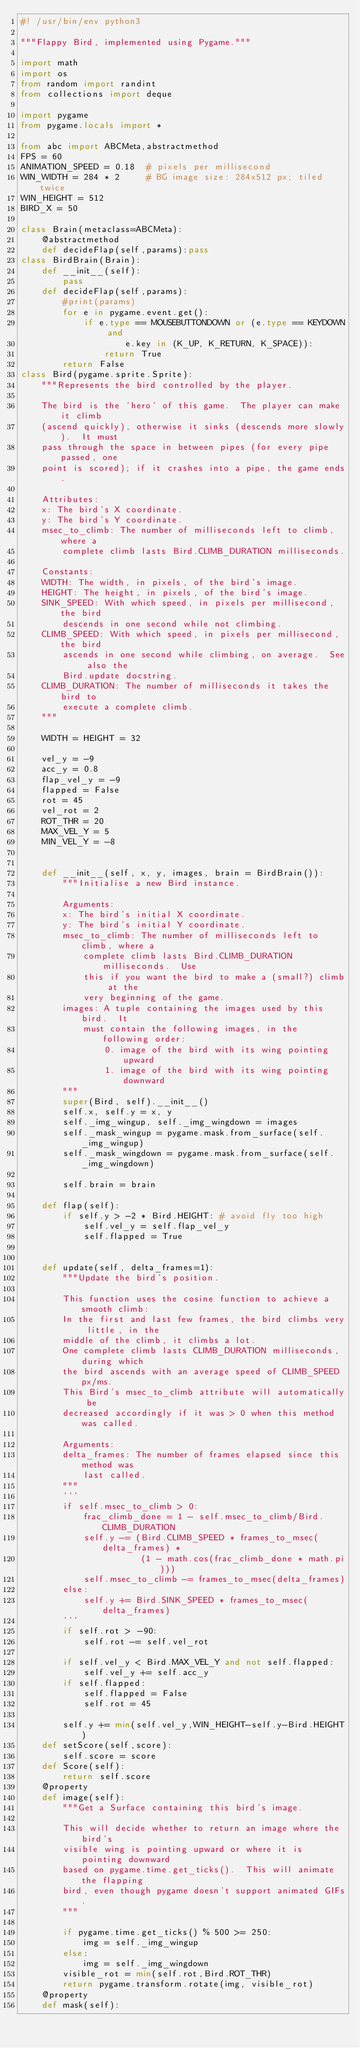Convert code to text. <code><loc_0><loc_0><loc_500><loc_500><_Python_>#! /usr/bin/env python3

"""Flappy Bird, implemented using Pygame."""

import math
import os
from random import randint
from collections import deque

import pygame
from pygame.locals import *

from abc import ABCMeta,abstractmethod
FPS = 60
ANIMATION_SPEED = 0.18  # pixels per millisecond
WIN_WIDTH = 284 * 2     # BG image size: 284x512 px; tiled twice
WIN_HEIGHT = 512
BIRD_X = 50

class Brain(metaclass=ABCMeta):
    @abstractmethod
    def decideFlap(self,params):pass
class BirdBrain(Brain):
    def __init__(self):
        pass
    def decideFlap(self,params):
        #print(params)
        for e in pygame.event.get(): 
            if e.type == MOUSEBUTTONDOWN or (e.type == KEYDOWN and
                    e.key in (K_UP, K_RETURN, K_SPACE)):
                return True
        return False
class Bird(pygame.sprite.Sprite):
    """Represents the bird controlled by the player.

    The bird is the 'hero' of this game.  The player can make it climb
    (ascend quickly), otherwise it sinks (descends more slowly).  It must
    pass through the space in between pipes (for every pipe passed, one
    point is scored); if it crashes into a pipe, the game ends.

    Attributes:
    x: The bird's X coordinate.
    y: The bird's Y coordinate.
    msec_to_climb: The number of milliseconds left to climb, where a
        complete climb lasts Bird.CLIMB_DURATION milliseconds.

    Constants:
    WIDTH: The width, in pixels, of the bird's image.
    HEIGHT: The height, in pixels, of the bird's image.
    SINK_SPEED: With which speed, in pixels per millisecond, the bird
        descends in one second while not climbing.
    CLIMB_SPEED: With which speed, in pixels per millisecond, the bird
        ascends in one second while climbing, on average.  See also the
        Bird.update docstring.
    CLIMB_DURATION: The number of milliseconds it takes the bird to
        execute a complete climb.
    """

    WIDTH = HEIGHT = 32

    vel_y = -9
    acc_y = 0.8
    flap_vel_y = -9
    flapped = False
    rot = 45
    vel_rot = 2
    ROT_THR = 20
    MAX_VEL_Y = 5
    MIN_VEL_Y = -8
    
    
    def __init__(self, x, y, images, brain = BirdBrain()):
        """Initialise a new Bird instance.

        Arguments:
        x: The bird's initial X coordinate.
        y: The bird's initial Y coordinate.
        msec_to_climb: The number of milliseconds left to climb, where a
            complete climb lasts Bird.CLIMB_DURATION milliseconds.  Use
            this if you want the bird to make a (small?) climb at the
            very beginning of the game.
        images: A tuple containing the images used by this bird.  It
            must contain the following images, in the following order:
                0. image of the bird with its wing pointing upward
                1. image of the bird with its wing pointing downward
        """
        super(Bird, self).__init__()
        self.x, self.y = x, y
        self._img_wingup, self._img_wingdown = images
        self._mask_wingup = pygame.mask.from_surface(self._img_wingup)
        self._mask_wingdown = pygame.mask.from_surface(self._img_wingdown)
    
        self.brain = brain
    
    def flap(self):
        if self.y > -2 * Bird.HEIGHT: # avoid fly too high
            self.vel_y = self.flap_vel_y
            self.flapped = True
        
        
    def update(self, delta_frames=1):
        """Update the bird's position.

        This function uses the cosine function to achieve a smooth climb:
        In the first and last few frames, the bird climbs very little, in the
        middle of the climb, it climbs a lot.
        One complete climb lasts CLIMB_DURATION milliseconds, during which
        the bird ascends with an average speed of CLIMB_SPEED px/ms.
        This Bird's msec_to_climb attribute will automatically be
        decreased accordingly if it was > 0 when this method was called.

        Arguments:
        delta_frames: The number of frames elapsed since this method was
            last called.
        """
        '''
        if self.msec_to_climb > 0:
            frac_climb_done = 1 - self.msec_to_climb/Bird.CLIMB_DURATION
            self.y -= (Bird.CLIMB_SPEED * frames_to_msec(delta_frames) *
                       (1 - math.cos(frac_climb_done * math.pi)))
            self.msec_to_climb -= frames_to_msec(delta_frames)
        else:
            self.y += Bird.SINK_SPEED * frames_to_msec(delta_frames)
        '''
        if self.rot > -90:
            self.rot -= self.vel_rot
        
        if self.vel_y < Bird.MAX_VEL_Y and not self.flapped:
            self.vel_y += self.acc_y
        if self.flapped:
            self.flapped = False
            self.rot = 45
            
        self.y += min(self.vel_y,WIN_HEIGHT-self.y-Bird.HEIGHT)
    def setScore(self,score):
        self.score = score
    def Score(self):
        return self.score    
    @property
    def image(self):
        """Get a Surface containing this bird's image.

        This will decide whether to return an image where the bird's
        visible wing is pointing upward or where it is pointing downward
        based on pygame.time.get_ticks().  This will animate the flapping
        bird, even though pygame doesn't support animated GIFs.
        """
        
        if pygame.time.get_ticks() % 500 >= 250:
            img = self._img_wingup
        else:
            img = self._img_wingdown
        visible_rot = min(self.rot,Bird.ROT_THR)
        return pygame.transform.rotate(img, visible_rot)
    @property
    def mask(self):</code> 